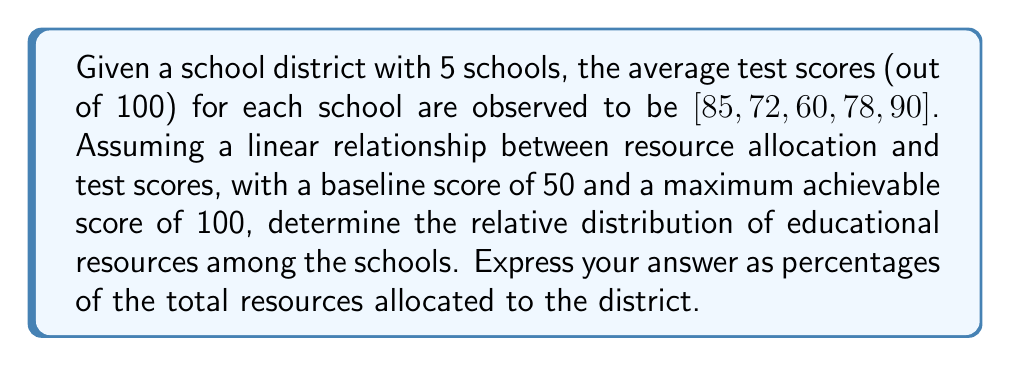Solve this math problem. To solve this inverse problem, we'll follow these steps:

1) First, let's establish our linear model:
   $$ \text{Score} = 50 + 50 \times \text{Resource Allocation} $$
   Where Resource Allocation is a value between 0 and 1.

2) For each school, we can calculate the resource allocation:
   $$ \text{Resource Allocation} = \frac{\text{Score} - 50}{50} $$

3) Let's calculate for each school:
   School 1: $\frac{85 - 50}{50} = 0.70$
   School 2: $\frac{72 - 50}{50} = 0.44$
   School 3: $\frac{60 - 50}{50} = 0.20$
   School 4: $\frac{78 - 50}{50} = 0.56$
   School 5: $\frac{90 - 50}{50} = 0.80$

4) Sum of all allocations: $0.70 + 0.44 + 0.20 + 0.56 + 0.80 = 2.70$

5) To get percentages, divide each allocation by the sum and multiply by 100:
   School 1: $\frac{0.70}{2.70} \times 100 \approx 25.93\%$
   School 2: $\frac{0.44}{2.70} \times 100 \approx 16.30\%$
   School 3: $\frac{0.20}{2.70} \times 100 \approx 7.41\%$
   School 4: $\frac{0.56}{2.70} \times 100 \approx 20.74\%$
   School 5: $\frac{0.80}{2.70} \times 100 \approx 29.63\%$
Answer: [25.93%, 16.30%, 7.41%, 20.74%, 29.63%] 